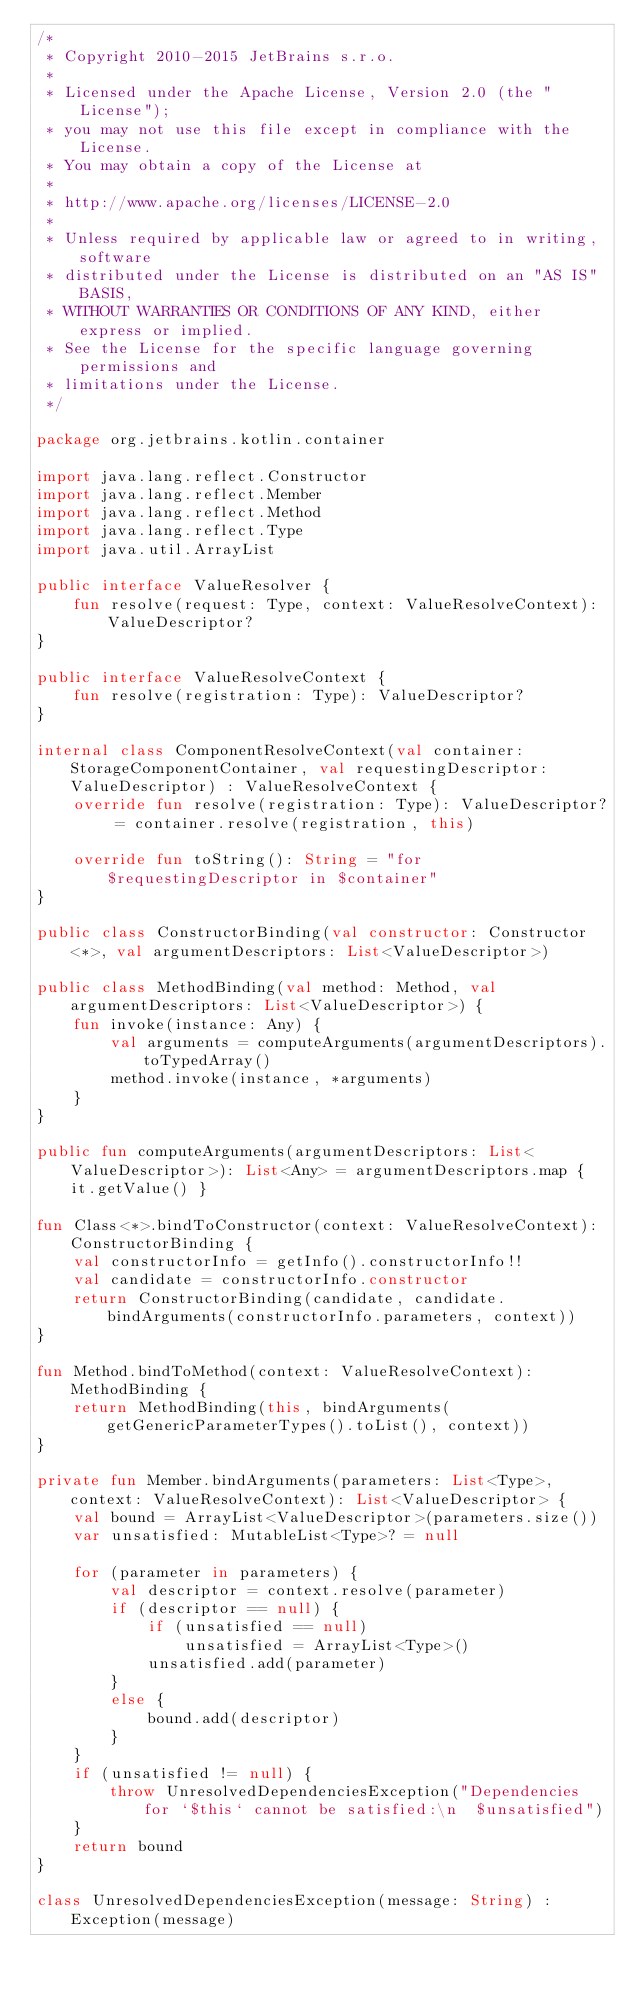<code> <loc_0><loc_0><loc_500><loc_500><_Kotlin_>/*
 * Copyright 2010-2015 JetBrains s.r.o.
 *
 * Licensed under the Apache License, Version 2.0 (the "License");
 * you may not use this file except in compliance with the License.
 * You may obtain a copy of the License at
 *
 * http://www.apache.org/licenses/LICENSE-2.0
 *
 * Unless required by applicable law or agreed to in writing, software
 * distributed under the License is distributed on an "AS IS" BASIS,
 * WITHOUT WARRANTIES OR CONDITIONS OF ANY KIND, either express or implied.
 * See the License for the specific language governing permissions and
 * limitations under the License.
 */

package org.jetbrains.kotlin.container

import java.lang.reflect.Constructor
import java.lang.reflect.Member
import java.lang.reflect.Method
import java.lang.reflect.Type
import java.util.ArrayList

public interface ValueResolver {
    fun resolve(request: Type, context: ValueResolveContext): ValueDescriptor?
}

public interface ValueResolveContext {
    fun resolve(registration: Type): ValueDescriptor?
}

internal class ComponentResolveContext(val container: StorageComponentContainer, val requestingDescriptor: ValueDescriptor) : ValueResolveContext {
    override fun resolve(registration: Type): ValueDescriptor? = container.resolve(registration, this)

    override fun toString(): String = "for $requestingDescriptor in $container"
}

public class ConstructorBinding(val constructor: Constructor<*>, val argumentDescriptors: List<ValueDescriptor>)

public class MethodBinding(val method: Method, val argumentDescriptors: List<ValueDescriptor>) {
    fun invoke(instance: Any) {
        val arguments = computeArguments(argumentDescriptors).toTypedArray()
        method.invoke(instance, *arguments)
    }
}

public fun computeArguments(argumentDescriptors: List<ValueDescriptor>): List<Any> = argumentDescriptors.map { it.getValue() }

fun Class<*>.bindToConstructor(context: ValueResolveContext): ConstructorBinding {
    val constructorInfo = getInfo().constructorInfo!!
    val candidate = constructorInfo.constructor
    return ConstructorBinding(candidate, candidate.bindArguments(constructorInfo.parameters, context))
}

fun Method.bindToMethod(context: ValueResolveContext): MethodBinding {
    return MethodBinding(this, bindArguments(getGenericParameterTypes().toList(), context))
}

private fun Member.bindArguments(parameters: List<Type>, context: ValueResolveContext): List<ValueDescriptor> {
    val bound = ArrayList<ValueDescriptor>(parameters.size())
    var unsatisfied: MutableList<Type>? = null

    for (parameter in parameters) {
        val descriptor = context.resolve(parameter)
        if (descriptor == null) {
            if (unsatisfied == null)
                unsatisfied = ArrayList<Type>()
            unsatisfied.add(parameter)
        }
        else {
            bound.add(descriptor)
        }
    }
    if (unsatisfied != null) {
        throw UnresolvedDependenciesException("Dependencies for `$this` cannot be satisfied:\n  $unsatisfied")
    }
    return bound
}

class UnresolvedDependenciesException(message: String) : Exception(message)
</code> 